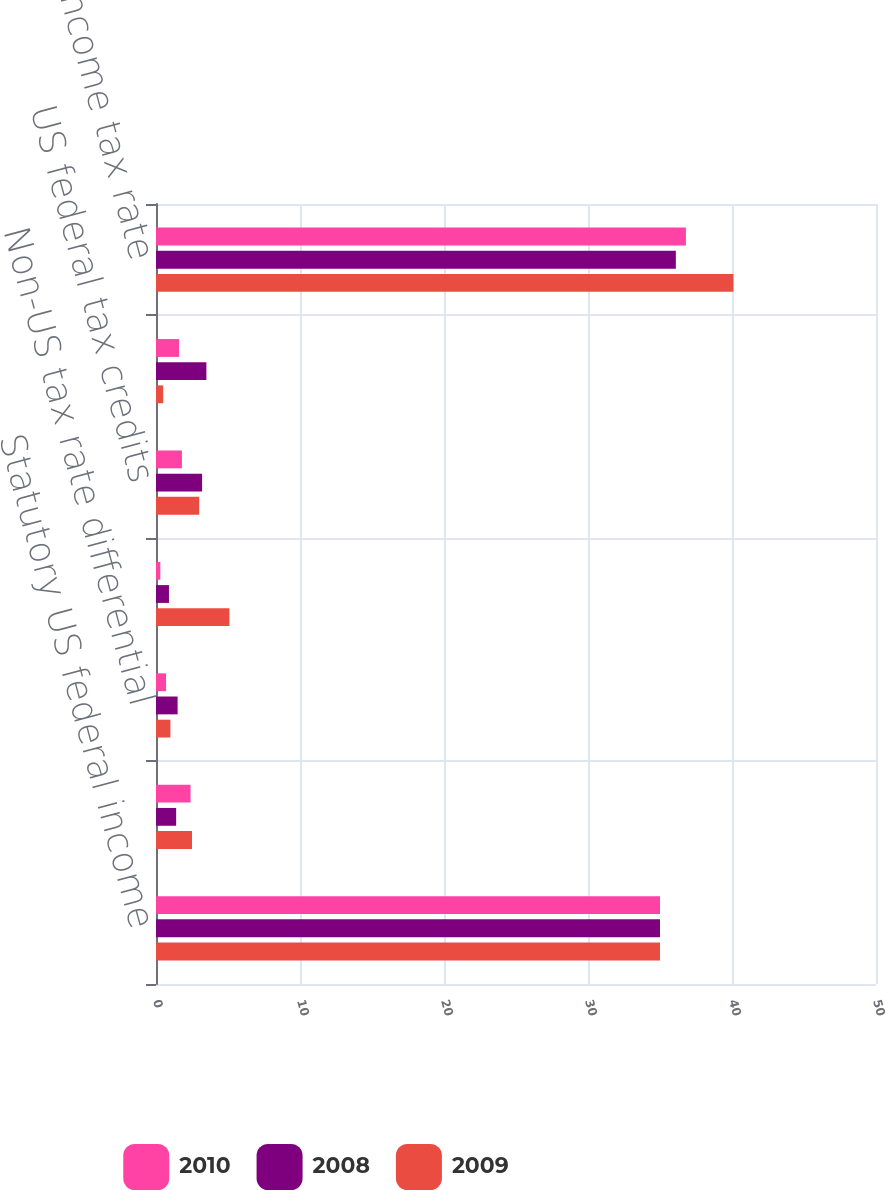Convert chart. <chart><loc_0><loc_0><loc_500><loc_500><stacked_bar_chart><ecel><fcel>Statutory US federal income<fcel>US state and local income<fcel>Non-US tax rate differential<fcel>Nondeductible/nontaxable items<fcel>US federal tax credits<fcel>Other<fcel>Effective income tax rate<nl><fcel>2010<fcel>35<fcel>2.4<fcel>0.7<fcel>0.3<fcel>1.8<fcel>1.6<fcel>36.8<nl><fcel>2008<fcel>35<fcel>1.4<fcel>1.5<fcel>0.9<fcel>3.2<fcel>3.5<fcel>36.1<nl><fcel>2009<fcel>35<fcel>2.5<fcel>1<fcel>5.1<fcel>3<fcel>0.5<fcel>40.1<nl></chart> 